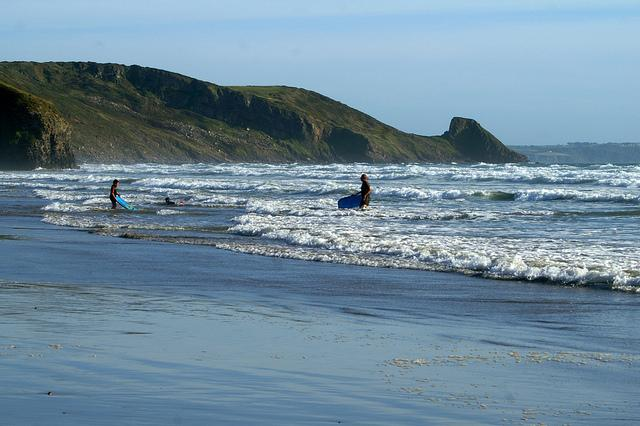What animal can usually be found here?

Choices:
A) elk
B) tiger
C) fish
D) koala bear fish 